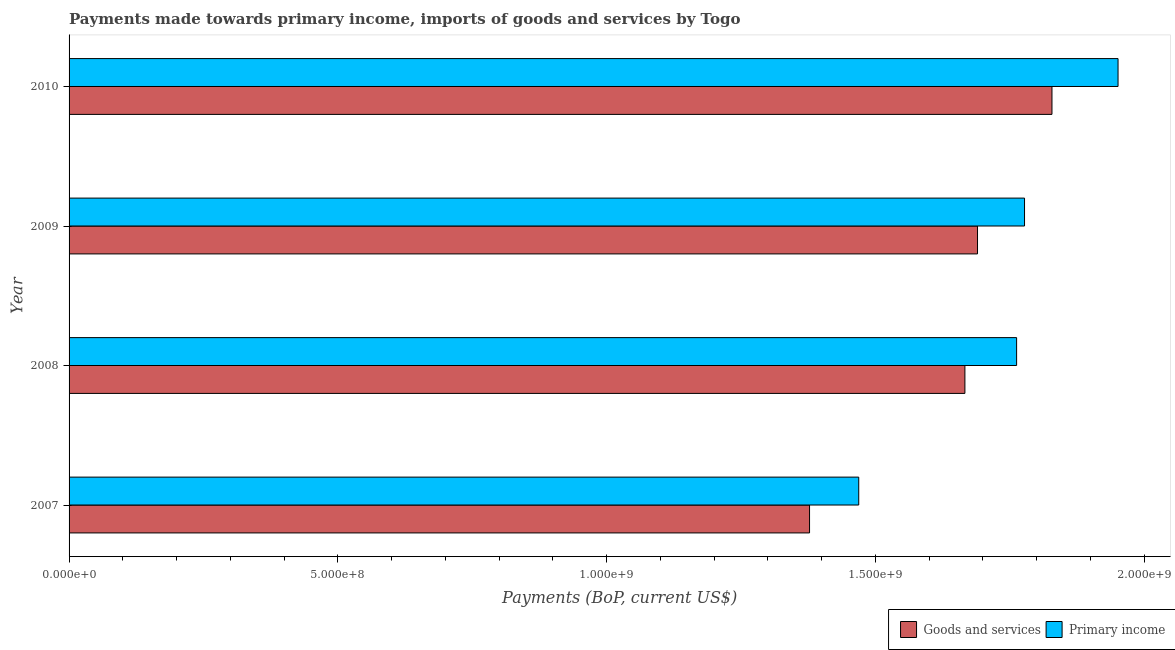Are the number of bars on each tick of the Y-axis equal?
Provide a short and direct response. Yes. How many bars are there on the 2nd tick from the bottom?
Offer a very short reply. 2. In how many cases, is the number of bars for a given year not equal to the number of legend labels?
Ensure brevity in your answer.  0. What is the payments made towards goods and services in 2009?
Provide a succinct answer. 1.69e+09. Across all years, what is the maximum payments made towards primary income?
Ensure brevity in your answer.  1.95e+09. Across all years, what is the minimum payments made towards primary income?
Offer a very short reply. 1.47e+09. What is the total payments made towards primary income in the graph?
Offer a very short reply. 6.96e+09. What is the difference between the payments made towards goods and services in 2008 and that in 2009?
Offer a terse response. -2.35e+07. What is the difference between the payments made towards goods and services in 2010 and the payments made towards primary income in 2009?
Ensure brevity in your answer.  5.10e+07. What is the average payments made towards primary income per year?
Make the answer very short. 1.74e+09. In the year 2008, what is the difference between the payments made towards primary income and payments made towards goods and services?
Offer a very short reply. 9.62e+07. In how many years, is the payments made towards goods and services greater than 800000000 US$?
Provide a short and direct response. 4. What is the ratio of the payments made towards primary income in 2007 to that in 2008?
Provide a short and direct response. 0.83. Is the payments made towards goods and services in 2007 less than that in 2009?
Your response must be concise. Yes. What is the difference between the highest and the second highest payments made towards primary income?
Offer a terse response. 1.74e+08. What is the difference between the highest and the lowest payments made towards primary income?
Your answer should be very brief. 4.82e+08. In how many years, is the payments made towards goods and services greater than the average payments made towards goods and services taken over all years?
Keep it short and to the point. 3. What does the 1st bar from the top in 2007 represents?
Make the answer very short. Primary income. What does the 2nd bar from the bottom in 2008 represents?
Ensure brevity in your answer.  Primary income. Are all the bars in the graph horizontal?
Offer a terse response. Yes. How many years are there in the graph?
Offer a terse response. 4. Are the values on the major ticks of X-axis written in scientific E-notation?
Offer a terse response. Yes. What is the title of the graph?
Give a very brief answer. Payments made towards primary income, imports of goods and services by Togo. Does "Travel services" appear as one of the legend labels in the graph?
Your response must be concise. No. What is the label or title of the X-axis?
Your answer should be compact. Payments (BoP, current US$). What is the label or title of the Y-axis?
Give a very brief answer. Year. What is the Payments (BoP, current US$) in Goods and services in 2007?
Offer a very short reply. 1.38e+09. What is the Payments (BoP, current US$) of Primary income in 2007?
Your response must be concise. 1.47e+09. What is the Payments (BoP, current US$) of Goods and services in 2008?
Your response must be concise. 1.67e+09. What is the Payments (BoP, current US$) in Primary income in 2008?
Your answer should be very brief. 1.76e+09. What is the Payments (BoP, current US$) of Goods and services in 2009?
Your answer should be very brief. 1.69e+09. What is the Payments (BoP, current US$) of Primary income in 2009?
Your answer should be compact. 1.78e+09. What is the Payments (BoP, current US$) in Goods and services in 2010?
Give a very brief answer. 1.83e+09. What is the Payments (BoP, current US$) of Primary income in 2010?
Offer a terse response. 1.95e+09. Across all years, what is the maximum Payments (BoP, current US$) in Goods and services?
Your response must be concise. 1.83e+09. Across all years, what is the maximum Payments (BoP, current US$) of Primary income?
Offer a terse response. 1.95e+09. Across all years, what is the minimum Payments (BoP, current US$) of Goods and services?
Offer a terse response. 1.38e+09. Across all years, what is the minimum Payments (BoP, current US$) in Primary income?
Keep it short and to the point. 1.47e+09. What is the total Payments (BoP, current US$) of Goods and services in the graph?
Ensure brevity in your answer.  6.56e+09. What is the total Payments (BoP, current US$) in Primary income in the graph?
Offer a very short reply. 6.96e+09. What is the difference between the Payments (BoP, current US$) in Goods and services in 2007 and that in 2008?
Offer a very short reply. -2.89e+08. What is the difference between the Payments (BoP, current US$) of Primary income in 2007 and that in 2008?
Your answer should be compact. -2.94e+08. What is the difference between the Payments (BoP, current US$) of Goods and services in 2007 and that in 2009?
Provide a succinct answer. -3.12e+08. What is the difference between the Payments (BoP, current US$) of Primary income in 2007 and that in 2009?
Offer a very short reply. -3.08e+08. What is the difference between the Payments (BoP, current US$) of Goods and services in 2007 and that in 2010?
Your response must be concise. -4.51e+08. What is the difference between the Payments (BoP, current US$) of Primary income in 2007 and that in 2010?
Your answer should be very brief. -4.82e+08. What is the difference between the Payments (BoP, current US$) in Goods and services in 2008 and that in 2009?
Your answer should be compact. -2.35e+07. What is the difference between the Payments (BoP, current US$) of Primary income in 2008 and that in 2009?
Your answer should be compact. -1.47e+07. What is the difference between the Payments (BoP, current US$) of Goods and services in 2008 and that in 2010?
Give a very brief answer. -1.62e+08. What is the difference between the Payments (BoP, current US$) of Primary income in 2008 and that in 2010?
Ensure brevity in your answer.  -1.89e+08. What is the difference between the Payments (BoP, current US$) of Goods and services in 2009 and that in 2010?
Offer a very short reply. -1.38e+08. What is the difference between the Payments (BoP, current US$) of Primary income in 2009 and that in 2010?
Provide a short and direct response. -1.74e+08. What is the difference between the Payments (BoP, current US$) of Goods and services in 2007 and the Payments (BoP, current US$) of Primary income in 2008?
Ensure brevity in your answer.  -3.85e+08. What is the difference between the Payments (BoP, current US$) in Goods and services in 2007 and the Payments (BoP, current US$) in Primary income in 2009?
Your answer should be compact. -4.00e+08. What is the difference between the Payments (BoP, current US$) of Goods and services in 2007 and the Payments (BoP, current US$) of Primary income in 2010?
Keep it short and to the point. -5.74e+08. What is the difference between the Payments (BoP, current US$) of Goods and services in 2008 and the Payments (BoP, current US$) of Primary income in 2009?
Offer a terse response. -1.11e+08. What is the difference between the Payments (BoP, current US$) of Goods and services in 2008 and the Payments (BoP, current US$) of Primary income in 2010?
Give a very brief answer. -2.85e+08. What is the difference between the Payments (BoP, current US$) in Goods and services in 2009 and the Payments (BoP, current US$) in Primary income in 2010?
Your answer should be compact. -2.61e+08. What is the average Payments (BoP, current US$) of Goods and services per year?
Your response must be concise. 1.64e+09. What is the average Payments (BoP, current US$) in Primary income per year?
Ensure brevity in your answer.  1.74e+09. In the year 2007, what is the difference between the Payments (BoP, current US$) in Goods and services and Payments (BoP, current US$) in Primary income?
Make the answer very short. -9.15e+07. In the year 2008, what is the difference between the Payments (BoP, current US$) in Goods and services and Payments (BoP, current US$) in Primary income?
Make the answer very short. -9.62e+07. In the year 2009, what is the difference between the Payments (BoP, current US$) of Goods and services and Payments (BoP, current US$) of Primary income?
Your response must be concise. -8.74e+07. In the year 2010, what is the difference between the Payments (BoP, current US$) of Goods and services and Payments (BoP, current US$) of Primary income?
Provide a short and direct response. -1.23e+08. What is the ratio of the Payments (BoP, current US$) in Goods and services in 2007 to that in 2008?
Your answer should be compact. 0.83. What is the ratio of the Payments (BoP, current US$) of Primary income in 2007 to that in 2008?
Your answer should be compact. 0.83. What is the ratio of the Payments (BoP, current US$) of Goods and services in 2007 to that in 2009?
Give a very brief answer. 0.82. What is the ratio of the Payments (BoP, current US$) of Primary income in 2007 to that in 2009?
Offer a terse response. 0.83. What is the ratio of the Payments (BoP, current US$) of Goods and services in 2007 to that in 2010?
Your response must be concise. 0.75. What is the ratio of the Payments (BoP, current US$) in Primary income in 2007 to that in 2010?
Provide a short and direct response. 0.75. What is the ratio of the Payments (BoP, current US$) in Goods and services in 2008 to that in 2009?
Provide a short and direct response. 0.99. What is the ratio of the Payments (BoP, current US$) of Goods and services in 2008 to that in 2010?
Keep it short and to the point. 0.91. What is the ratio of the Payments (BoP, current US$) in Primary income in 2008 to that in 2010?
Offer a very short reply. 0.9. What is the ratio of the Payments (BoP, current US$) of Goods and services in 2009 to that in 2010?
Provide a succinct answer. 0.92. What is the ratio of the Payments (BoP, current US$) in Primary income in 2009 to that in 2010?
Keep it short and to the point. 0.91. What is the difference between the highest and the second highest Payments (BoP, current US$) of Goods and services?
Your answer should be very brief. 1.38e+08. What is the difference between the highest and the second highest Payments (BoP, current US$) of Primary income?
Provide a short and direct response. 1.74e+08. What is the difference between the highest and the lowest Payments (BoP, current US$) of Goods and services?
Offer a terse response. 4.51e+08. What is the difference between the highest and the lowest Payments (BoP, current US$) in Primary income?
Provide a short and direct response. 4.82e+08. 